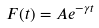Convert formula to latex. <formula><loc_0><loc_0><loc_500><loc_500>F ( t ) = A e ^ { - \gamma t }</formula> 